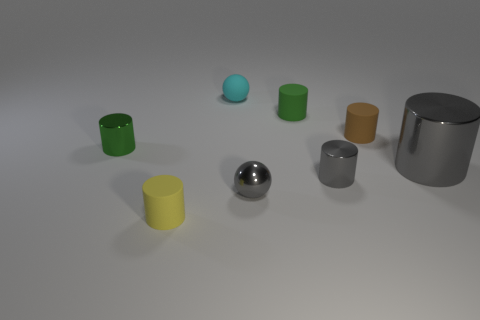There is a metallic cylinder left of the green cylinder that is to the right of the cyan matte ball; what is its color?
Provide a short and direct response. Green. What number of other objects are the same material as the tiny gray cylinder?
Provide a short and direct response. 3. Is the number of cylinders on the left side of the yellow rubber cylinder the same as the number of small brown things?
Provide a short and direct response. Yes. What material is the small ball that is in front of the metallic thing that is on the left side of the matte cylinder that is in front of the big metallic thing made of?
Your answer should be compact. Metal. There is a ball that is in front of the large thing; what is its color?
Keep it short and to the point. Gray. Is there anything else that is the same shape as the brown matte object?
Give a very brief answer. Yes. There is a rubber cylinder that is on the right side of the green rubber cylinder that is behind the big gray shiny object; how big is it?
Ensure brevity in your answer.  Small. Is the number of tiny green rubber things right of the yellow thing the same as the number of tiny cyan spheres left of the tiny green metallic thing?
Your response must be concise. No. There is a small ball that is made of the same material as the big object; what is its color?
Your answer should be compact. Gray. Is the cyan sphere made of the same material as the small green cylinder that is on the right side of the yellow matte cylinder?
Ensure brevity in your answer.  Yes. 